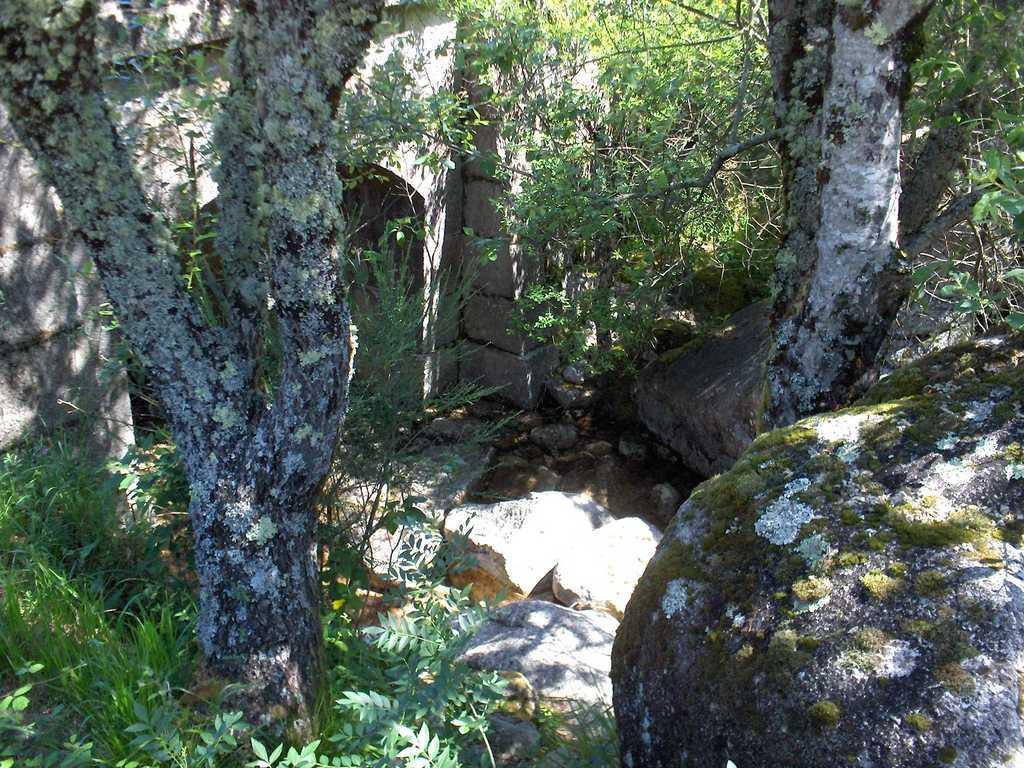Describe this image in one or two sentences. In this image we can see a bark of a tree, plants, grass, stones, trees and a wall. 